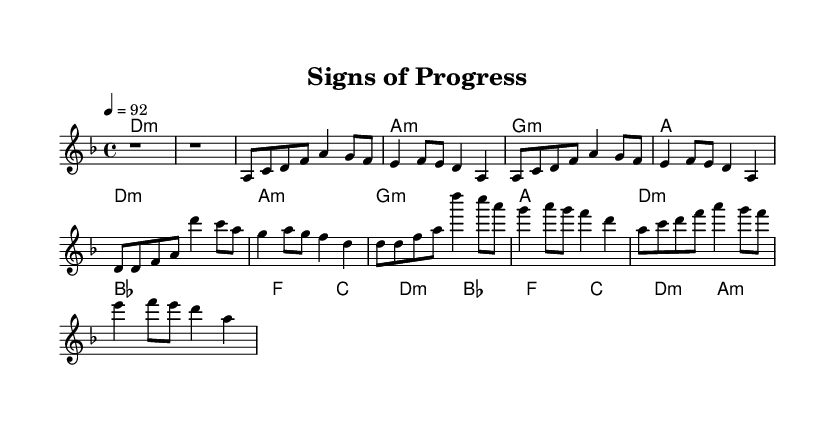What is the key signature of this music? The key signature is D minor, which contains one flat (B flat). You can identify the key signature by looking to the left side of the staff where the flats or sharps are indicated.
Answer: D minor What is the time signature of this music? The time signature is 4/4, which means there are four beats in each measure, and the quarter note gets one beat. This is indicated at the beginning of the score after the key signature.
Answer: 4/4 What is the tempo marking of this piece? The tempo marking is quarter note equals 92, which indicates that there should be 92 quarter note beats in a minute. This can be found under the global settings designation in the code.
Answer: 92 How many measures are in the verse section? There are 4 measures in the verse section, and you can count them by examining the melody and seeing how many distinct groups of music notated between the double bars there are.
Answer: 4 What chord follows the D minor in the chorus section? The chord that follows D minor in the chorus section is B flat major. This can be identified by reviewing the harmonic progression as noted in the chord changes.
Answer: B flat What is the repeating structure of the chorus? The structure of the chorus repeats two times with the same melody and chord progression each time. You can see this by noting the repeated sections annotated in the music for the chorus.
Answer: Repeated What unique element of communication does rap reveal through its structure? Rap music showcases the evolution of rhythmic speech patterns which convey meaning and emotions. This can be inferred by analyzing how the verses and choruses adapt structured melodies to enhance lyrical delivery.
Answer: Rhythmic speech 